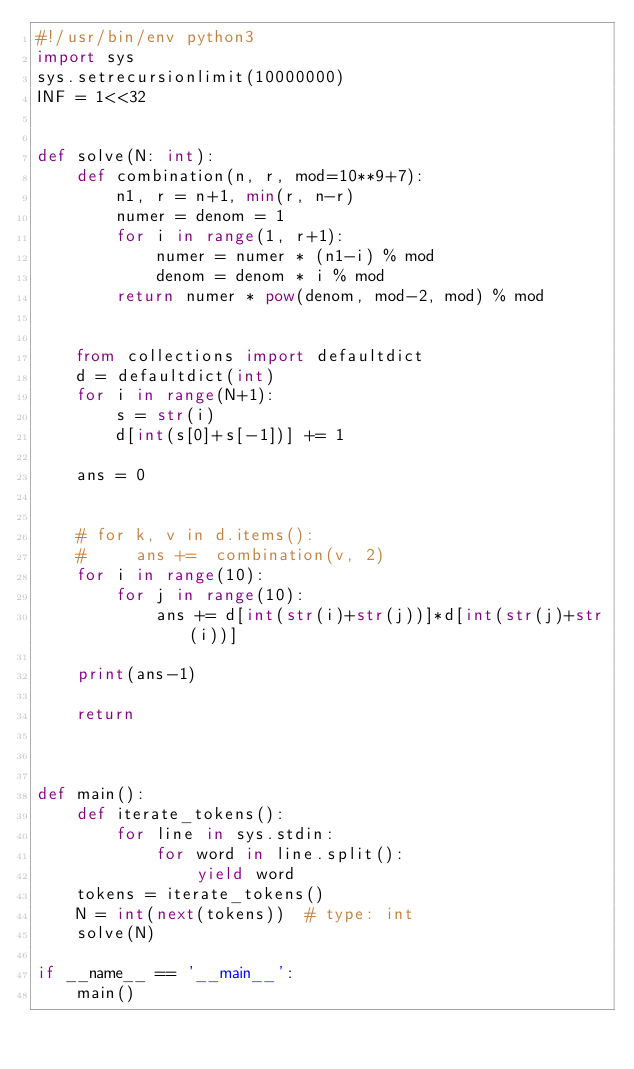<code> <loc_0><loc_0><loc_500><loc_500><_Python_>#!/usr/bin/env python3
import sys
sys.setrecursionlimit(10000000)
INF = 1<<32


def solve(N: int):
    def combination(n, r, mod=10**9+7):
        n1, r = n+1, min(r, n-r)
        numer = denom = 1
        for i in range(1, r+1):
            numer = numer * (n1-i) % mod
            denom = denom * i % mod
        return numer * pow(denom, mod-2, mod) % mod
    
    
    from collections import defaultdict
    d = defaultdict(int)
    for i in range(N+1):
        s = str(i)
        d[int(s[0]+s[-1])] += 1

    ans = 0


    # for k, v in d.items():
    #     ans +=  combination(v, 2)
    for i in range(10):
        for j in range(10):
            ans += d[int(str(i)+str(j))]*d[int(str(j)+str(i))]

    print(ans-1)

    return



def main():
    def iterate_tokens():
        for line in sys.stdin:
            for word in line.split():
                yield word
    tokens = iterate_tokens()
    N = int(next(tokens))  # type: int
    solve(N)

if __name__ == '__main__':
    main()
</code> 